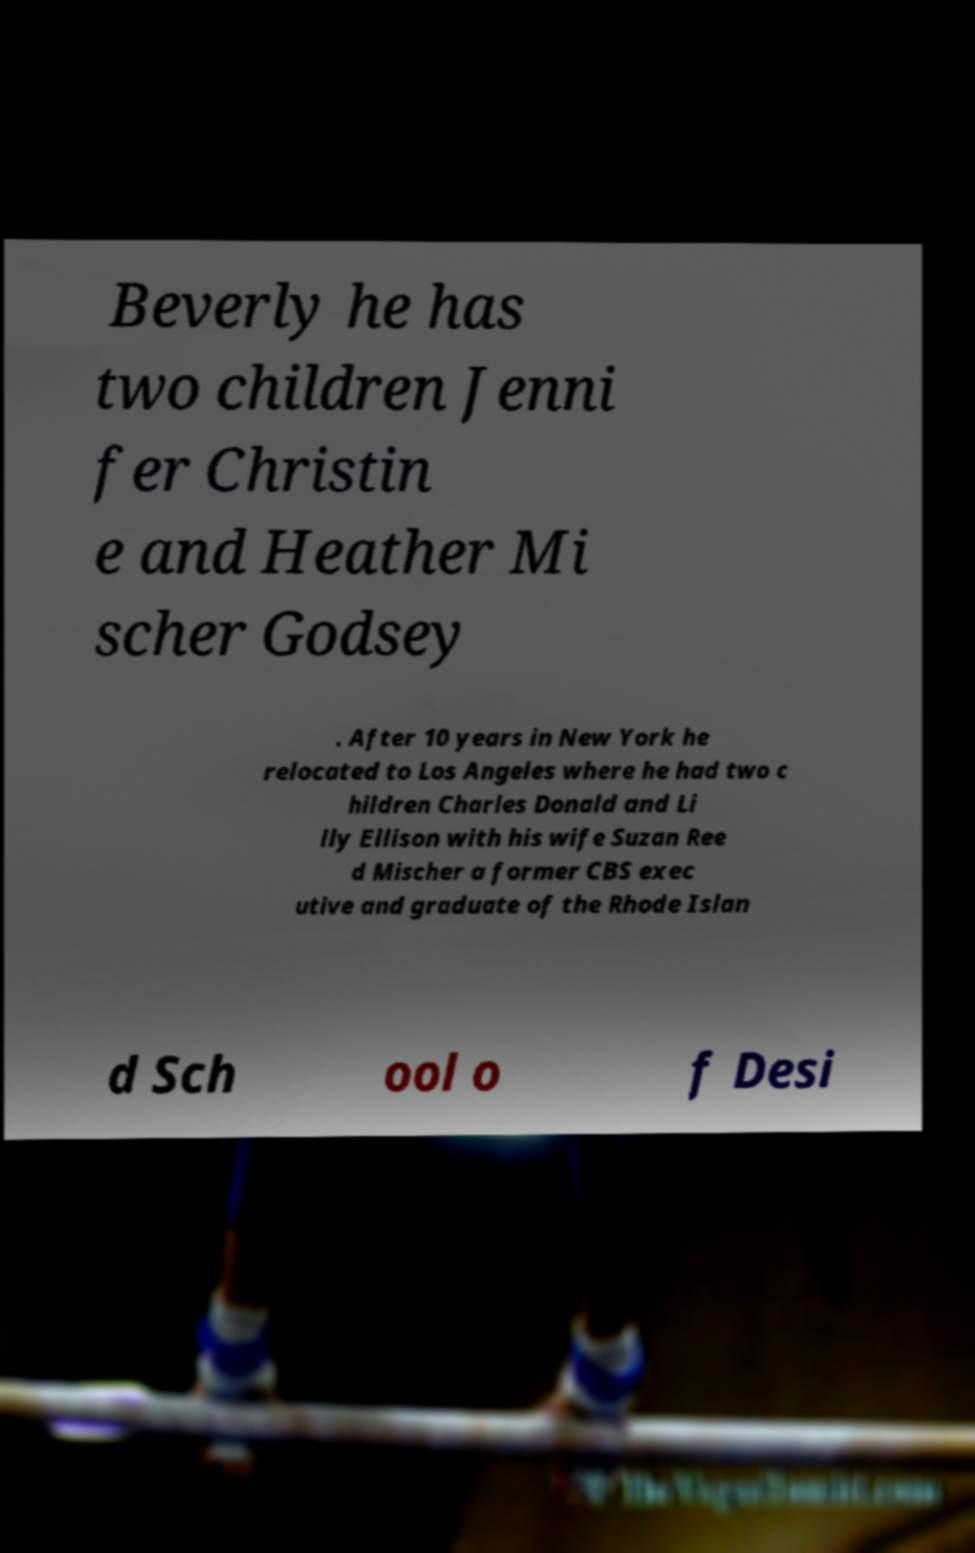Please identify and transcribe the text found in this image. Beverly he has two children Jenni fer Christin e and Heather Mi scher Godsey . After 10 years in New York he relocated to Los Angeles where he had two c hildren Charles Donald and Li lly Ellison with his wife Suzan Ree d Mischer a former CBS exec utive and graduate of the Rhode Islan d Sch ool o f Desi 